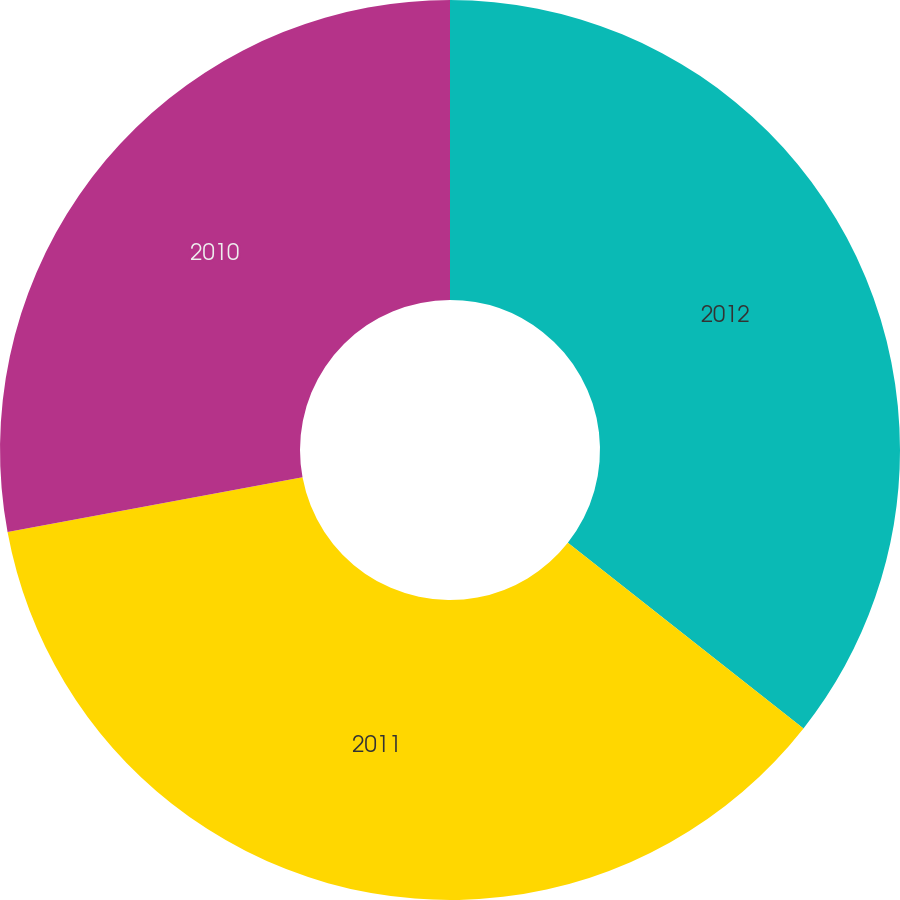<chart> <loc_0><loc_0><loc_500><loc_500><pie_chart><fcel>2012<fcel>2011<fcel>2010<nl><fcel>35.62%<fcel>36.46%<fcel>27.92%<nl></chart> 